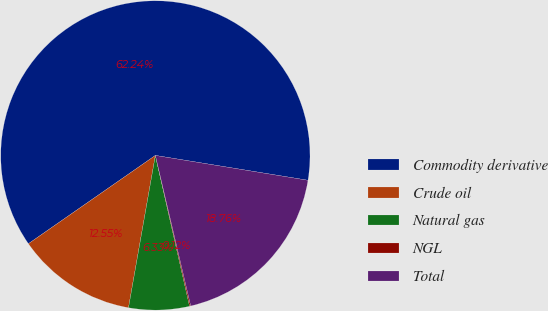Convert chart. <chart><loc_0><loc_0><loc_500><loc_500><pie_chart><fcel>Commodity derivative<fcel>Crude oil<fcel>Natural gas<fcel>NGL<fcel>Total<nl><fcel>62.24%<fcel>12.55%<fcel>6.33%<fcel>0.12%<fcel>18.76%<nl></chart> 